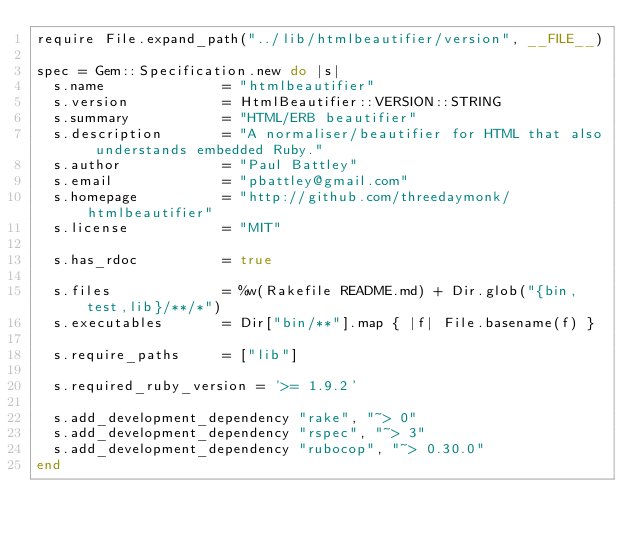Convert code to text. <code><loc_0><loc_0><loc_500><loc_500><_Ruby_>require File.expand_path("../lib/htmlbeautifier/version", __FILE__)

spec = Gem::Specification.new do |s|
  s.name              = "htmlbeautifier"
  s.version           = HtmlBeautifier::VERSION::STRING
  s.summary           = "HTML/ERB beautifier"
  s.description       = "A normaliser/beautifier for HTML that also understands embedded Ruby."
  s.author            = "Paul Battley"
  s.email             = "pbattley@gmail.com"
  s.homepage          = "http://github.com/threedaymonk/htmlbeautifier"
  s.license           = "MIT"

  s.has_rdoc          = true

  s.files             = %w(Rakefile README.md) + Dir.glob("{bin,test,lib}/**/*")
  s.executables       = Dir["bin/**"].map { |f| File.basename(f) }

  s.require_paths     = ["lib"]

  s.required_ruby_version = '>= 1.9.2'

  s.add_development_dependency "rake", "~> 0"
  s.add_development_dependency "rspec", "~> 3"
  s.add_development_dependency "rubocop", "~> 0.30.0"
end

</code> 